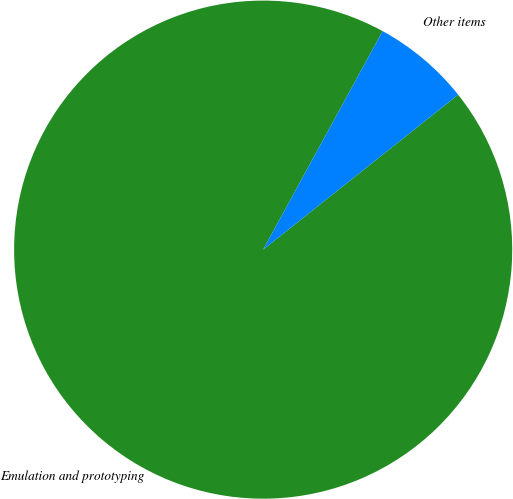Convert chart. <chart><loc_0><loc_0><loc_500><loc_500><pie_chart><fcel>Emulation and prototyping<fcel>Other items<nl><fcel>93.65%<fcel>6.35%<nl></chart> 